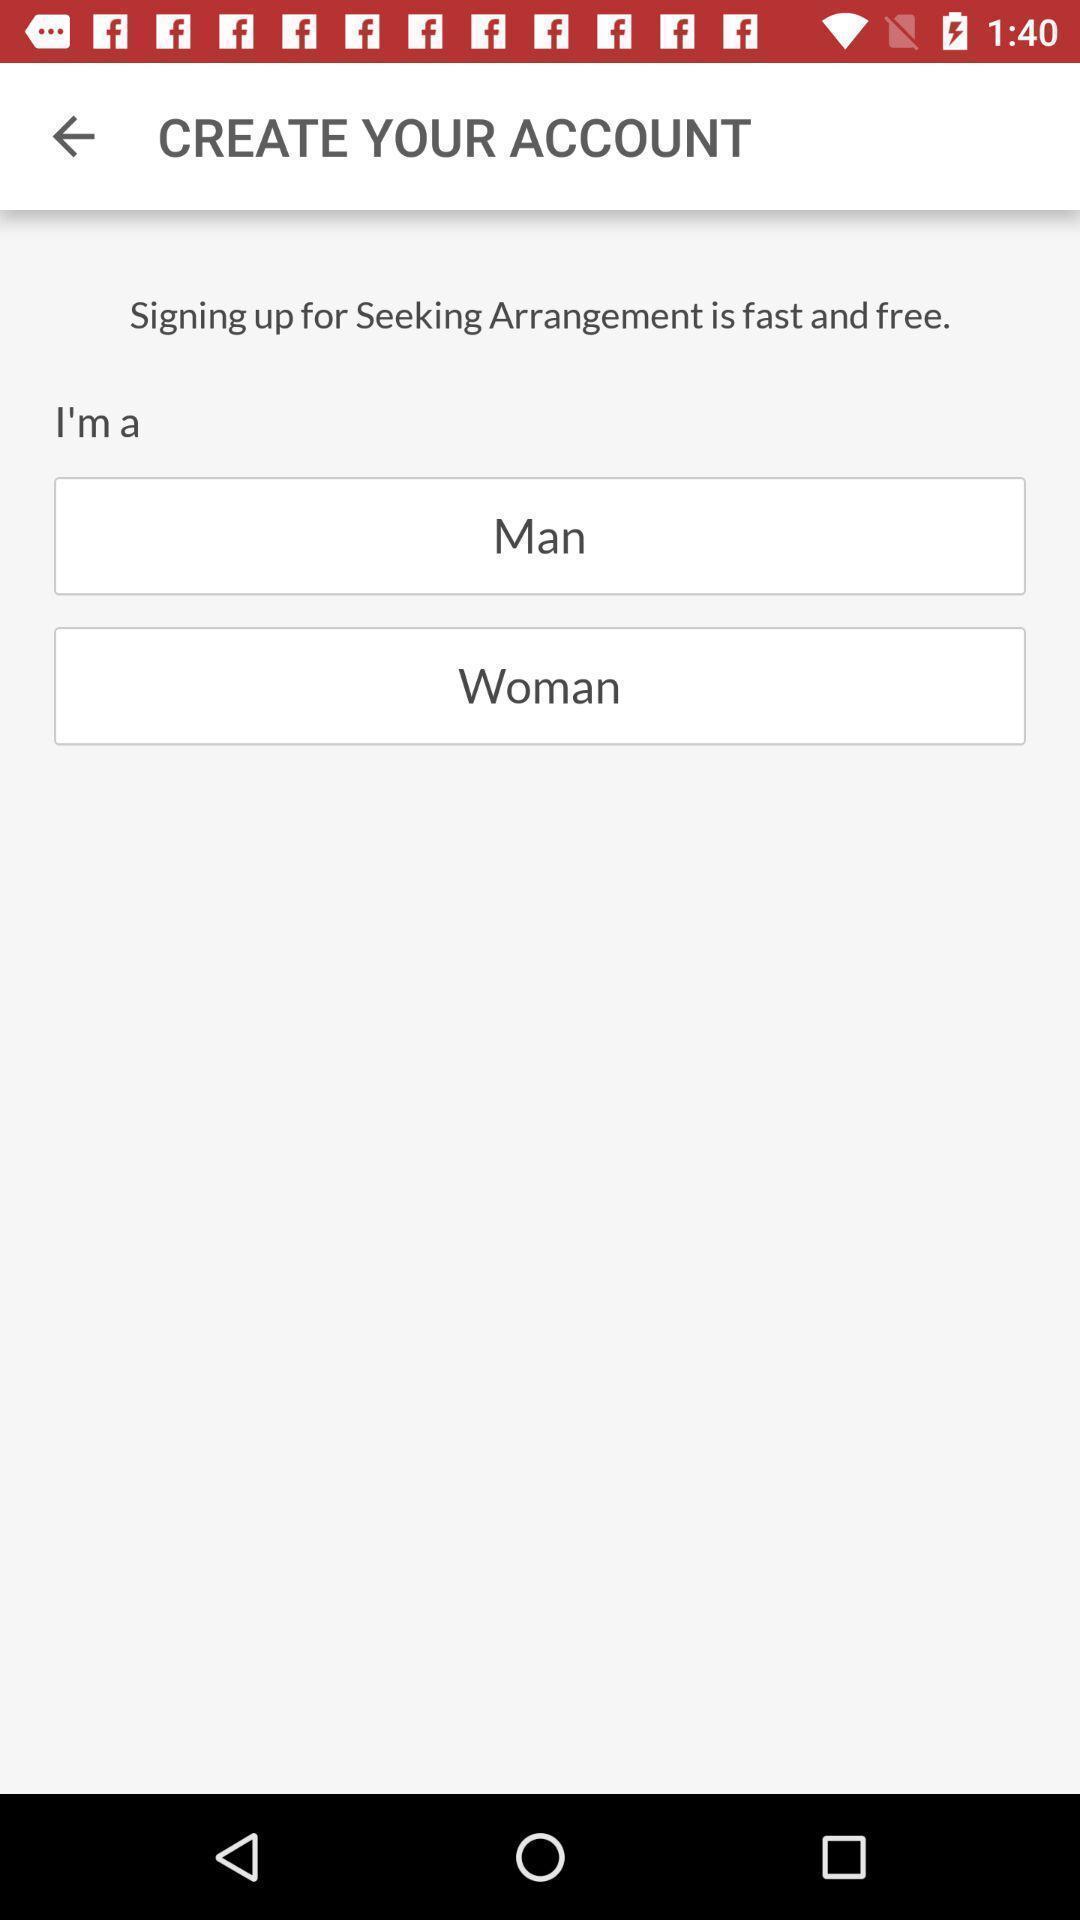Provide a detailed account of this screenshot. Page displays details to create your account. 